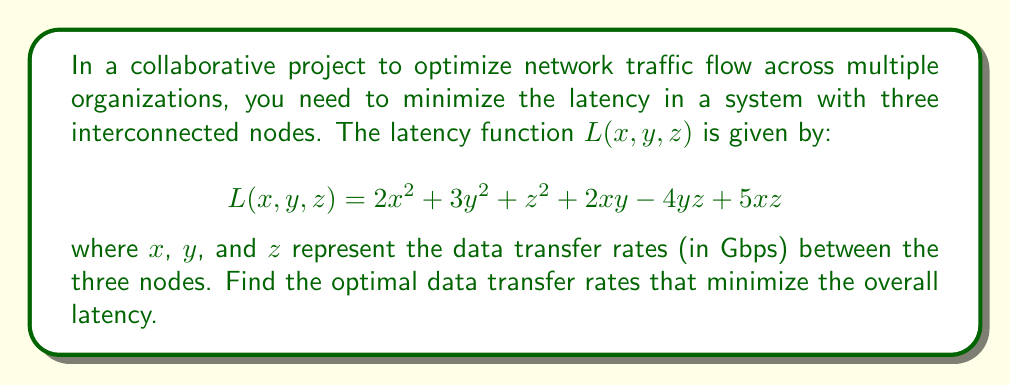Can you answer this question? To find the optimal data transfer rates that minimize the latency, we need to find the critical points of the function $L(x, y, z)$. We'll do this by taking partial derivatives with respect to $x$, $y$, and $z$, setting them equal to zero, and solving the resulting system of equations.

1. Take partial derivatives:

   $\frac{\partial L}{\partial x} = 4x + 2y + 5z$
   $\frac{\partial L}{\partial y} = 6y + 2x - 4z$
   $\frac{\partial L}{\partial z} = 2z - 4y + 5x$

2. Set each partial derivative to zero:

   $4x + 2y + 5z = 0$ ... (1)
   $2x + 6y - 4z = 0$ ... (2)
   $5x - 4y + 2z = 0$ ... (3)

3. Solve the system of equations:
   
   Multiply equation (1) by 2 and equation (2) by -1:
   
   $8x + 4y + 10z = 0$ ... (4)
   $-2x - 6y + 4z = 0$ ... (5)
   
   Add (4) and (5):
   
   $6x - 2y + 14z = 0$ ... (6)
   
   Now we have equations (3) and (6):
   
   $5x - 4y + 2z = 0$ ... (3)
   $6x - 2y + 14z = 0$ ... (6)
   
   Multiply (3) by 3 and (6) by -1:
   
   $15x - 12y + 6z = 0$ ... (7)
   $-6x + 2y - 14z = 0$ ... (8)
   
   Add (7) and (8):
   
   $9x - 10y - 8z = 0$ ... (9)
   
   From (9), we can express x in terms of y and z:
   
   $x = \frac{10y + 8z}{9}$ ... (10)
   
   Substitute (10) into (3):
   
   $5(\frac{10y + 8z}{9}) - 4y + 2z = 0$
   
   Simplify:
   
   $\frac{50y + 40z}{9} - 4y + 2z = 0$
   $50y + 40z - 36y - 18z = 0$
   $14y + 22z = 0$
   $y = -\frac{11z}{7}$ ... (11)
   
   Substitute (11) into (10):
   
   $x = \frac{10(-\frac{11z}{7}) + 8z}{9} = -\frac{110z}{63} + \frac{8z}{9} = -\frac{110z}{63} + \frac{56z}{63} = -\frac{54z}{63} = -\frac{6z}{7}$

4. The critical point is:

   $x = -\frac{6z}{7}$
   $y = -\frac{11z}{7}$
   $z = z$

   To find the actual values, we can choose any non-zero value for z. Let's choose $z = 7$ for simplicity:

   $x = -6$
   $y = -11$
   $z = 7$

5. To confirm this is a minimum, we need to check the second partial derivatives:

   $\frac{\partial^2 L}{\partial x^2} = 4$
   $\frac{\partial^2 L}{\partial y^2} = 6$
   $\frac{\partial^2 L}{\partial z^2} = 2$
   $\frac{\partial^2 L}{\partial x\partial y} = \frac{\partial^2 L}{\partial y\partial x} = 2$
   $\frac{\partial^2 L}{\partial y\partial z} = \frac{\partial^2 L}{\partial z\partial y} = -4$
   $\frac{\partial^2 L}{\partial x\partial z} = \frac{\partial^2 L}{\partial z\partial x} = 5$

   The Hessian matrix is positive definite, confirming this is a local minimum.

Therefore, the optimal data transfer rates that minimize the overall latency are in the ratio of -6 : -11 : 7 for x : y : z respectively.
Answer: $x : y : z = -6 : -11 : 7$ 